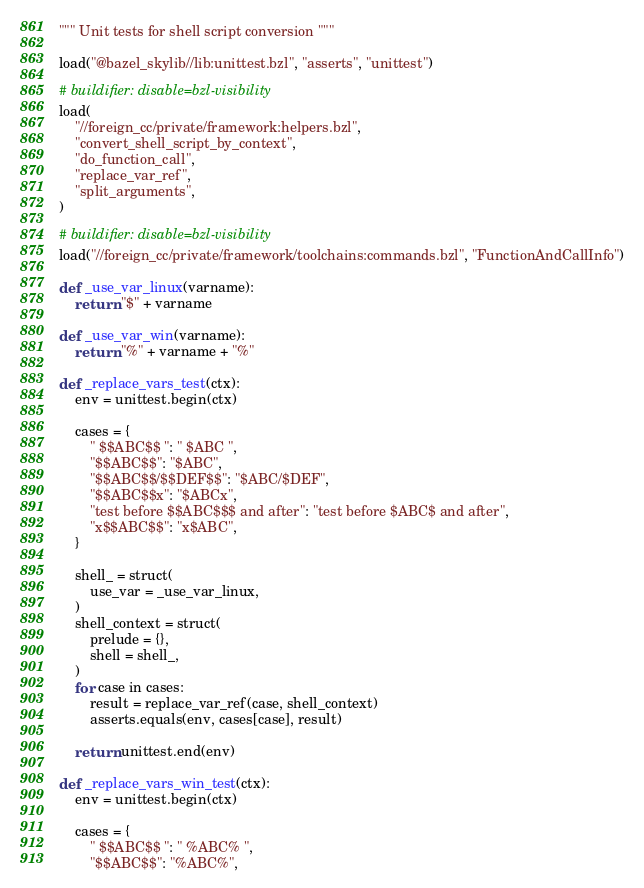Convert code to text. <code><loc_0><loc_0><loc_500><loc_500><_Python_>""" Unit tests for shell script conversion """

load("@bazel_skylib//lib:unittest.bzl", "asserts", "unittest")

# buildifier: disable=bzl-visibility
load(
    "//foreign_cc/private/framework:helpers.bzl",
    "convert_shell_script_by_context",
    "do_function_call",
    "replace_var_ref",
    "split_arguments",
)

# buildifier: disable=bzl-visibility
load("//foreign_cc/private/framework/toolchains:commands.bzl", "FunctionAndCallInfo")

def _use_var_linux(varname):
    return "$" + varname

def _use_var_win(varname):
    return "%" + varname + "%"

def _replace_vars_test(ctx):
    env = unittest.begin(ctx)

    cases = {
        " $$ABC$$ ": " $ABC ",
        "$$ABC$$": "$ABC",
        "$$ABC$$/$$DEF$$": "$ABC/$DEF",
        "$$ABC$$x": "$ABCx",
        "test before $$ABC$$$ and after": "test before $ABC$ and after",
        "x$$ABC$$": "x$ABC",
    }

    shell_ = struct(
        use_var = _use_var_linux,
    )
    shell_context = struct(
        prelude = {},
        shell = shell_,
    )
    for case in cases:
        result = replace_var_ref(case, shell_context)
        asserts.equals(env, cases[case], result)

    return unittest.end(env)

def _replace_vars_win_test(ctx):
    env = unittest.begin(ctx)

    cases = {
        " $$ABC$$ ": " %ABC% ",
        "$$ABC$$": "%ABC%",</code> 